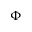<formula> <loc_0><loc_0><loc_500><loc_500>\Phi</formula> 